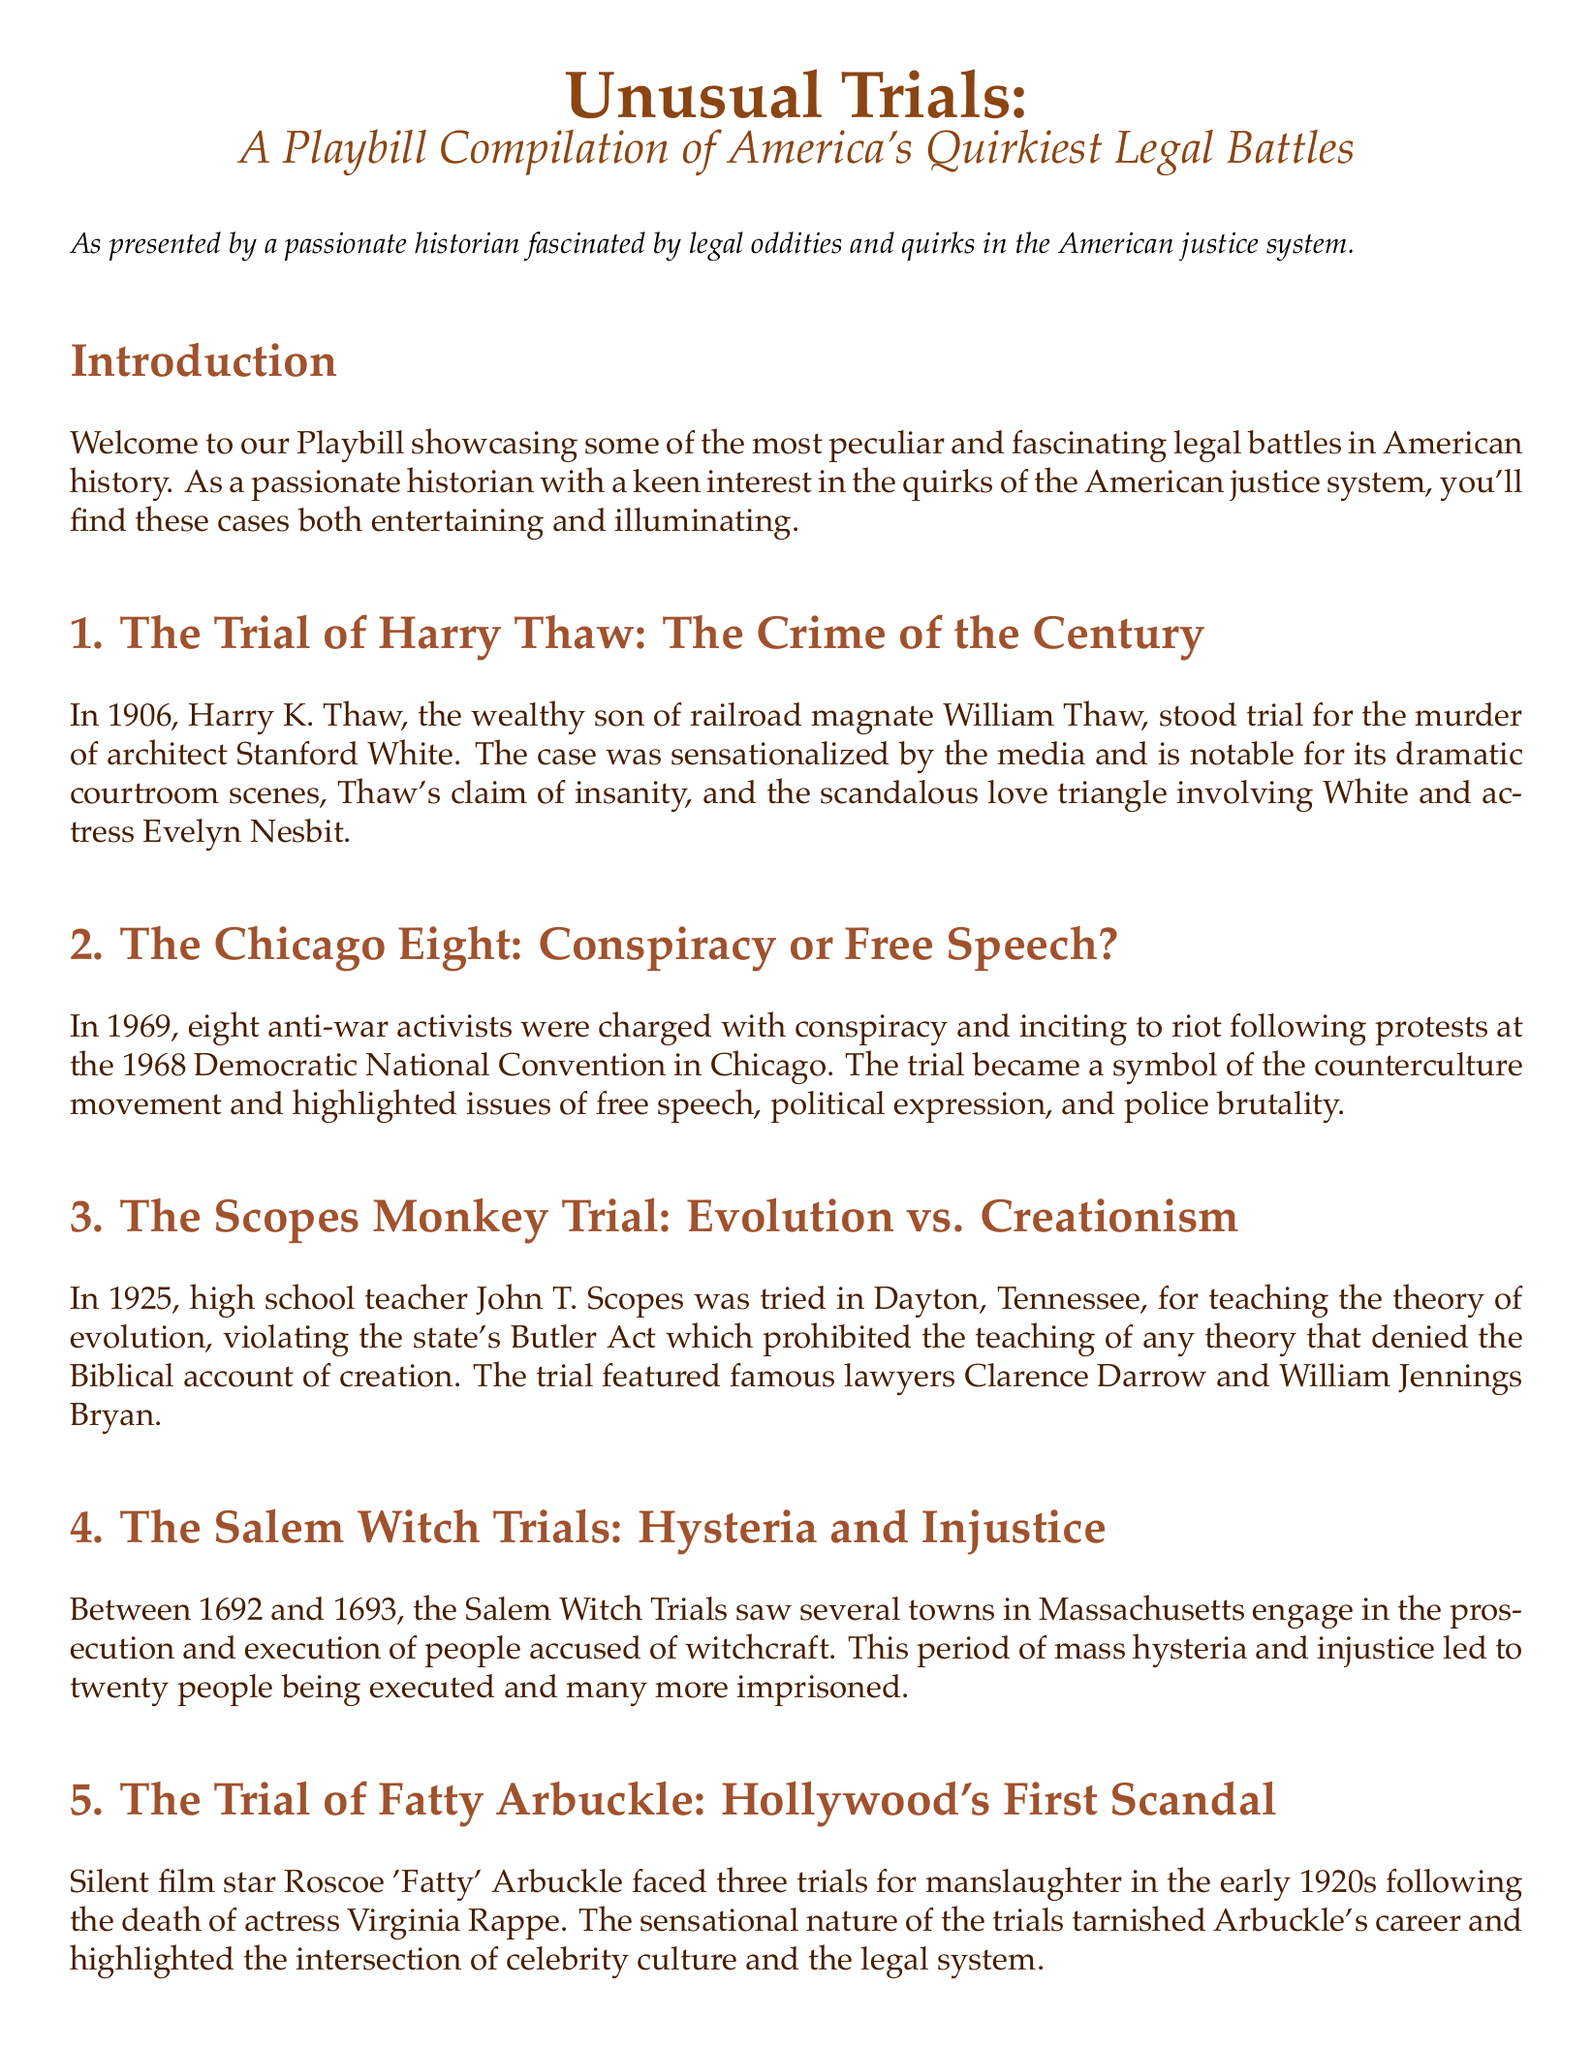What year did the Trial of Harry Thaw take place? The year of Harry Thaw's trial is mentioned in the document as 1906.
Answer: 1906 Who was the architect murdered by Harry Thaw? The document specifies that Harry Thaw murdered architect Stanford White.
Answer: Stanford White What was at the center of the Scopes Monkey Trial? The central issue of the Scopes Monkey Trial was the teaching of evolution in schools as stated in the document.
Answer: Evolution How many people were executed during the Salem Witch Trials? The document notes that twenty people were executed during the Salem Witch Trials.
Answer: Twenty Which silent film star faced trials for manslaughter? The document indicates that Roscoe 'Fatty' Arbuckle faced trials for manslaughter.
Answer: Roscoe 'Fatty' Arbuckle What broader issues do these legal battles reflect according to the conclusion? The conclusion mentions that these legal battles reflect broader societal issues and challenges.
Answer: Societal issues What does the Chicago Eight trial symbolize? The trial of the Chicago Eight became a symbol of the counterculture movement according to the document.
Answer: Counterculture movement Which famous lawyers were involved in the Scopes Monkey Trial? The document lists Clarence Darrow and William Jennings Bryan as the famous lawyers involved in the trial.
Answer: Clarence Darrow and William Jennings Bryan 